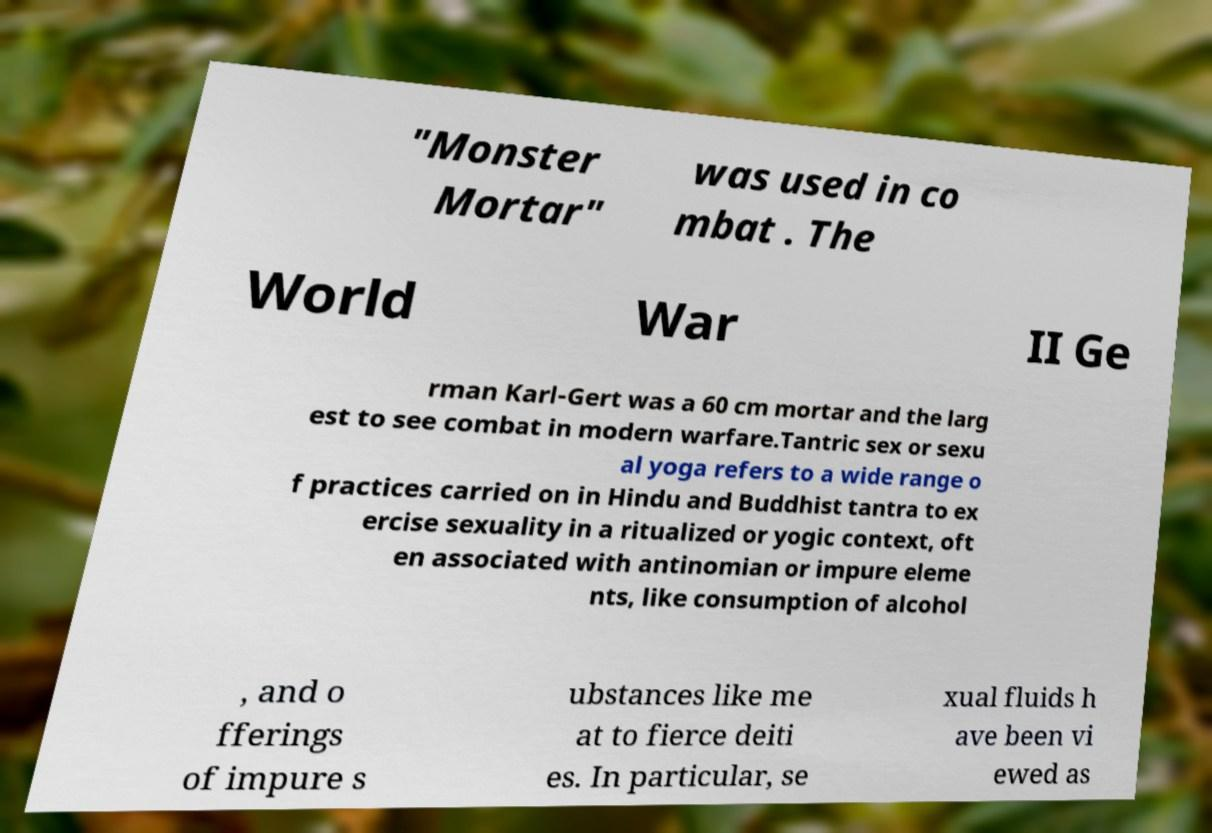Could you assist in decoding the text presented in this image and type it out clearly? "Monster Mortar" was used in co mbat . The World War II Ge rman Karl-Gert was a 60 cm mortar and the larg est to see combat in modern warfare.Tantric sex or sexu al yoga refers to a wide range o f practices carried on in Hindu and Buddhist tantra to ex ercise sexuality in a ritualized or yogic context, oft en associated with antinomian or impure eleme nts, like consumption of alcohol , and o fferings of impure s ubstances like me at to fierce deiti es. In particular, se xual fluids h ave been vi ewed as 